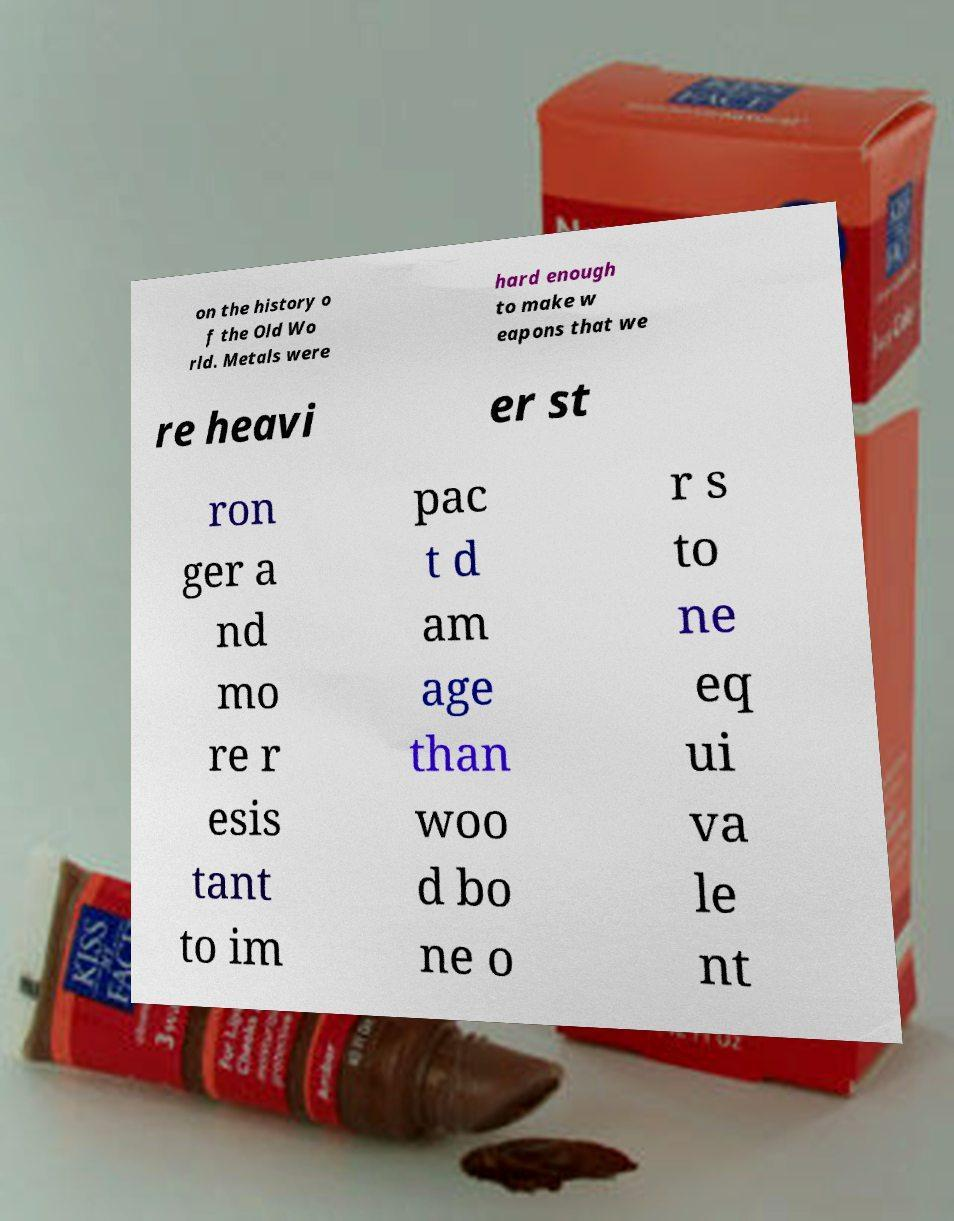I need the written content from this picture converted into text. Can you do that? on the history o f the Old Wo rld. Metals were hard enough to make w eapons that we re heavi er st ron ger a nd mo re r esis tant to im pac t d am age than woo d bo ne o r s to ne eq ui va le nt 